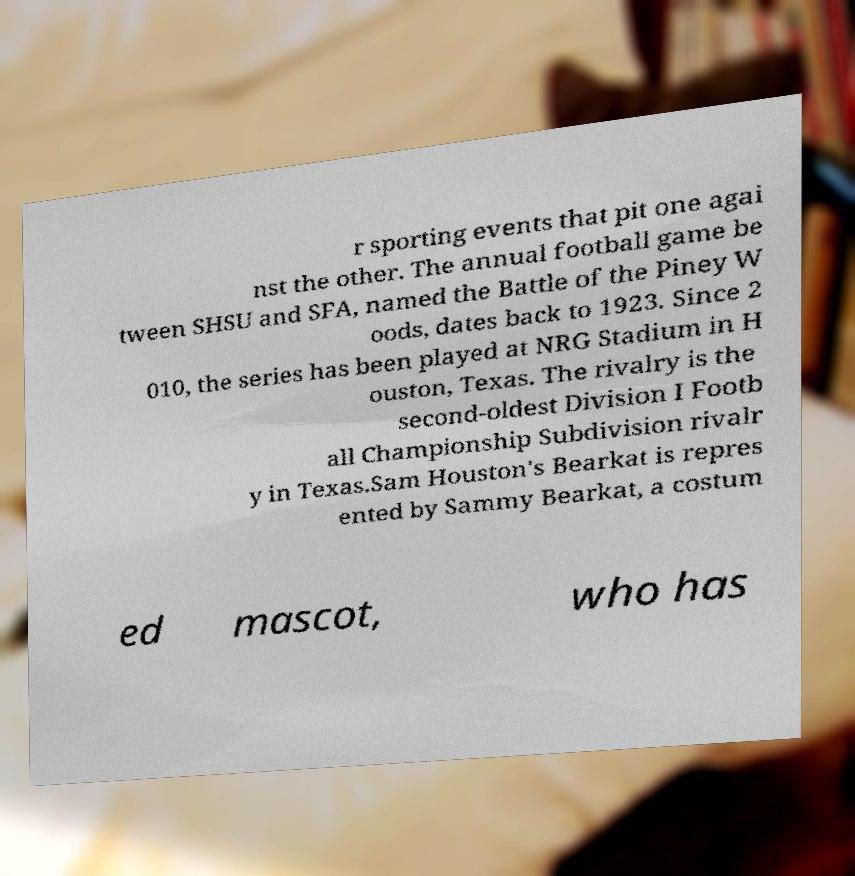Please read and relay the text visible in this image. What does it say? r sporting events that pit one agai nst the other. The annual football game be tween SHSU and SFA, named the Battle of the Piney W oods, dates back to 1923. Since 2 010, the series has been played at NRG Stadium in H ouston, Texas. The rivalry is the second-oldest Division I Footb all Championship Subdivision rivalr y in Texas.Sam Houston's Bearkat is repres ented by Sammy Bearkat, a costum ed mascot, who has 